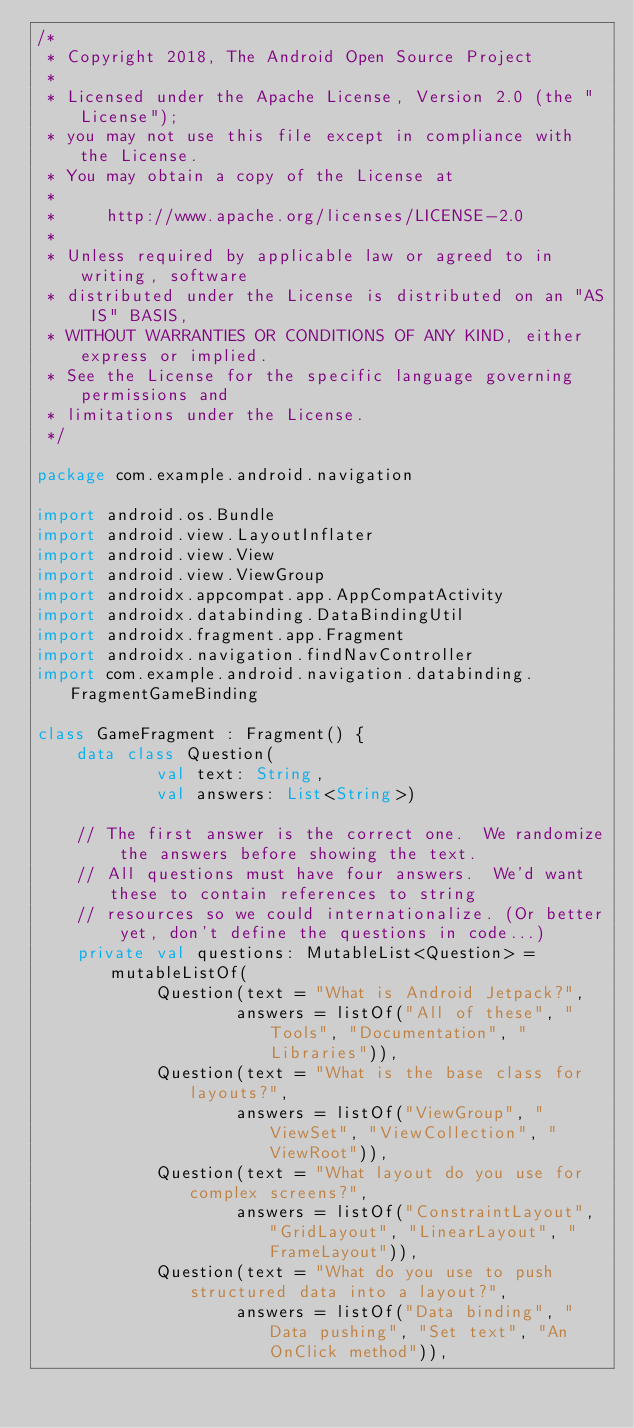Convert code to text. <code><loc_0><loc_0><loc_500><loc_500><_Kotlin_>/*
 * Copyright 2018, The Android Open Source Project
 *
 * Licensed under the Apache License, Version 2.0 (the "License");
 * you may not use this file except in compliance with the License.
 * You may obtain a copy of the License at
 *
 *     http://www.apache.org/licenses/LICENSE-2.0
 *
 * Unless required by applicable law or agreed to in writing, software
 * distributed under the License is distributed on an "AS IS" BASIS,
 * WITHOUT WARRANTIES OR CONDITIONS OF ANY KIND, either express or implied.
 * See the License for the specific language governing permissions and
 * limitations under the License.
 */

package com.example.android.navigation

import android.os.Bundle
import android.view.LayoutInflater
import android.view.View
import android.view.ViewGroup
import androidx.appcompat.app.AppCompatActivity
import androidx.databinding.DataBindingUtil
import androidx.fragment.app.Fragment
import androidx.navigation.findNavController
import com.example.android.navigation.databinding.FragmentGameBinding

class GameFragment : Fragment() {
    data class Question(
            val text: String,
            val answers: List<String>)

    // The first answer is the correct one.  We randomize the answers before showing the text.
    // All questions must have four answers.  We'd want these to contain references to string
    // resources so we could internationalize. (Or better yet, don't define the questions in code...)
    private val questions: MutableList<Question> = mutableListOf(
            Question(text = "What is Android Jetpack?",
                    answers = listOf("All of these", "Tools", "Documentation", "Libraries")),
            Question(text = "What is the base class for layouts?",
                    answers = listOf("ViewGroup", "ViewSet", "ViewCollection", "ViewRoot")),
            Question(text = "What layout do you use for complex screens?",
                    answers = listOf("ConstraintLayout", "GridLayout", "LinearLayout", "FrameLayout")),
            Question(text = "What do you use to push structured data into a layout?",
                    answers = listOf("Data binding", "Data pushing", "Set text", "An OnClick method")),</code> 